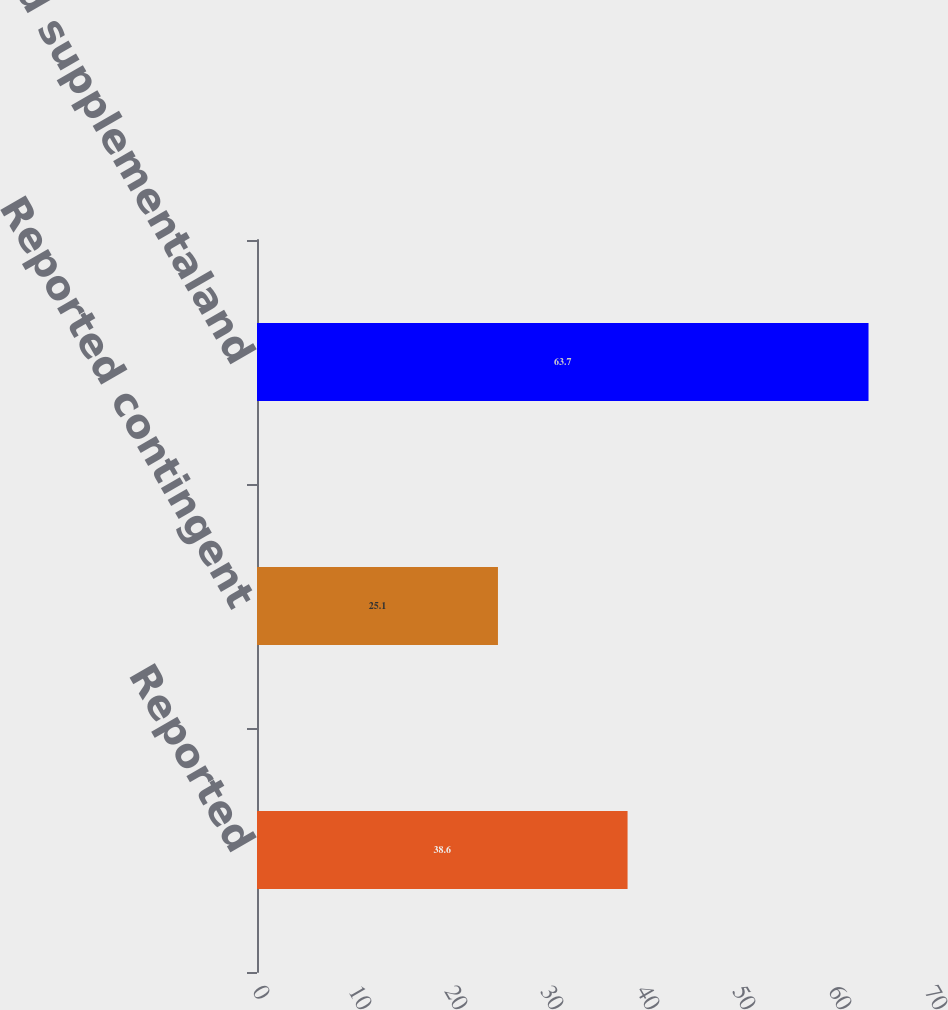Convert chart. <chart><loc_0><loc_0><loc_500><loc_500><bar_chart><fcel>Reported<fcel>Reported contingent<fcel>Reported supplementaland<nl><fcel>38.6<fcel>25.1<fcel>63.7<nl></chart> 